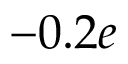Convert formula to latex. <formula><loc_0><loc_0><loc_500><loc_500>- 0 . 2 e</formula> 